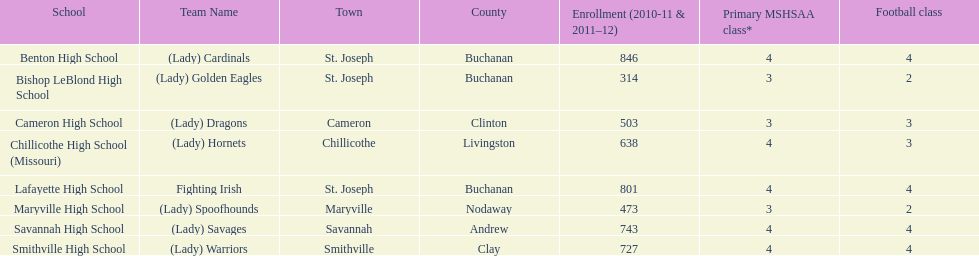Does lafayette high school or benton high school have green and grey as their colors? Lafayette High School. 